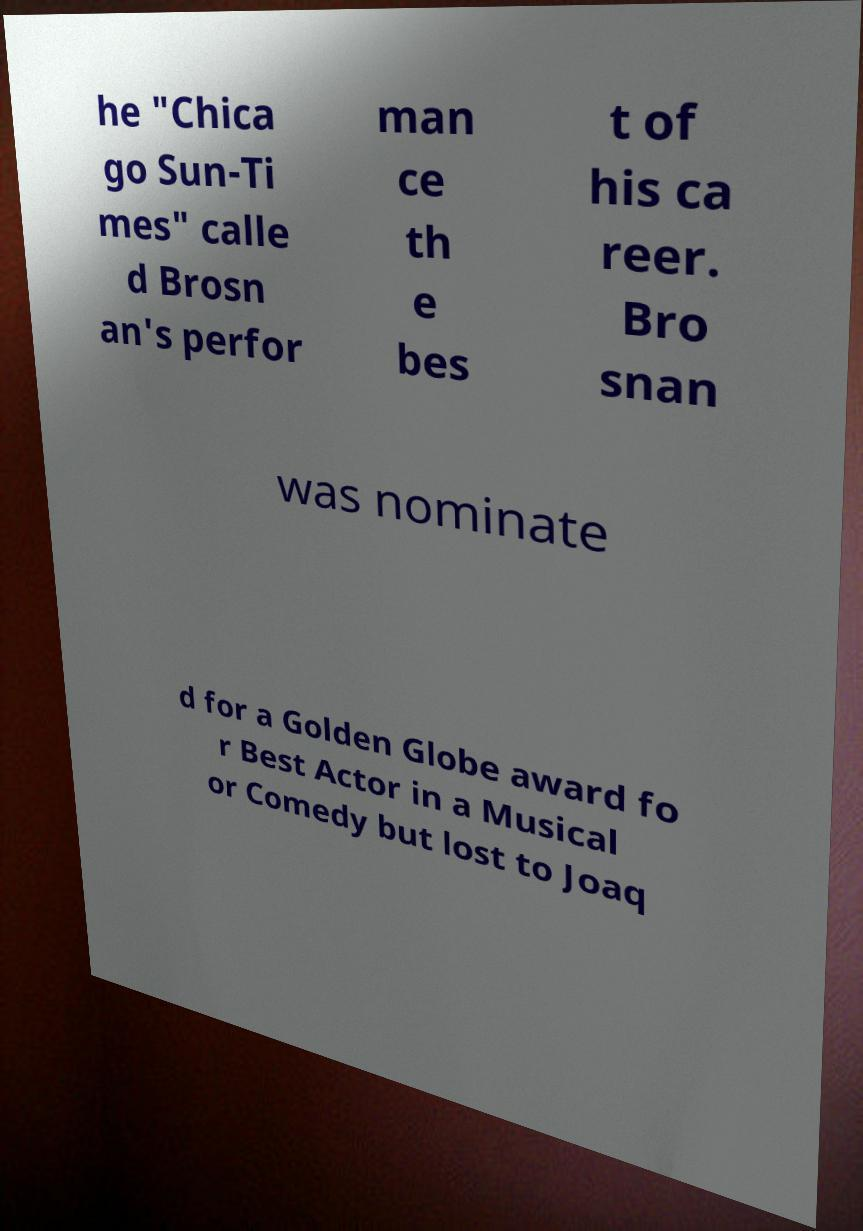Could you assist in decoding the text presented in this image and type it out clearly? he "Chica go Sun-Ti mes" calle d Brosn an's perfor man ce th e bes t of his ca reer. Bro snan was nominate d for a Golden Globe award fo r Best Actor in a Musical or Comedy but lost to Joaq 